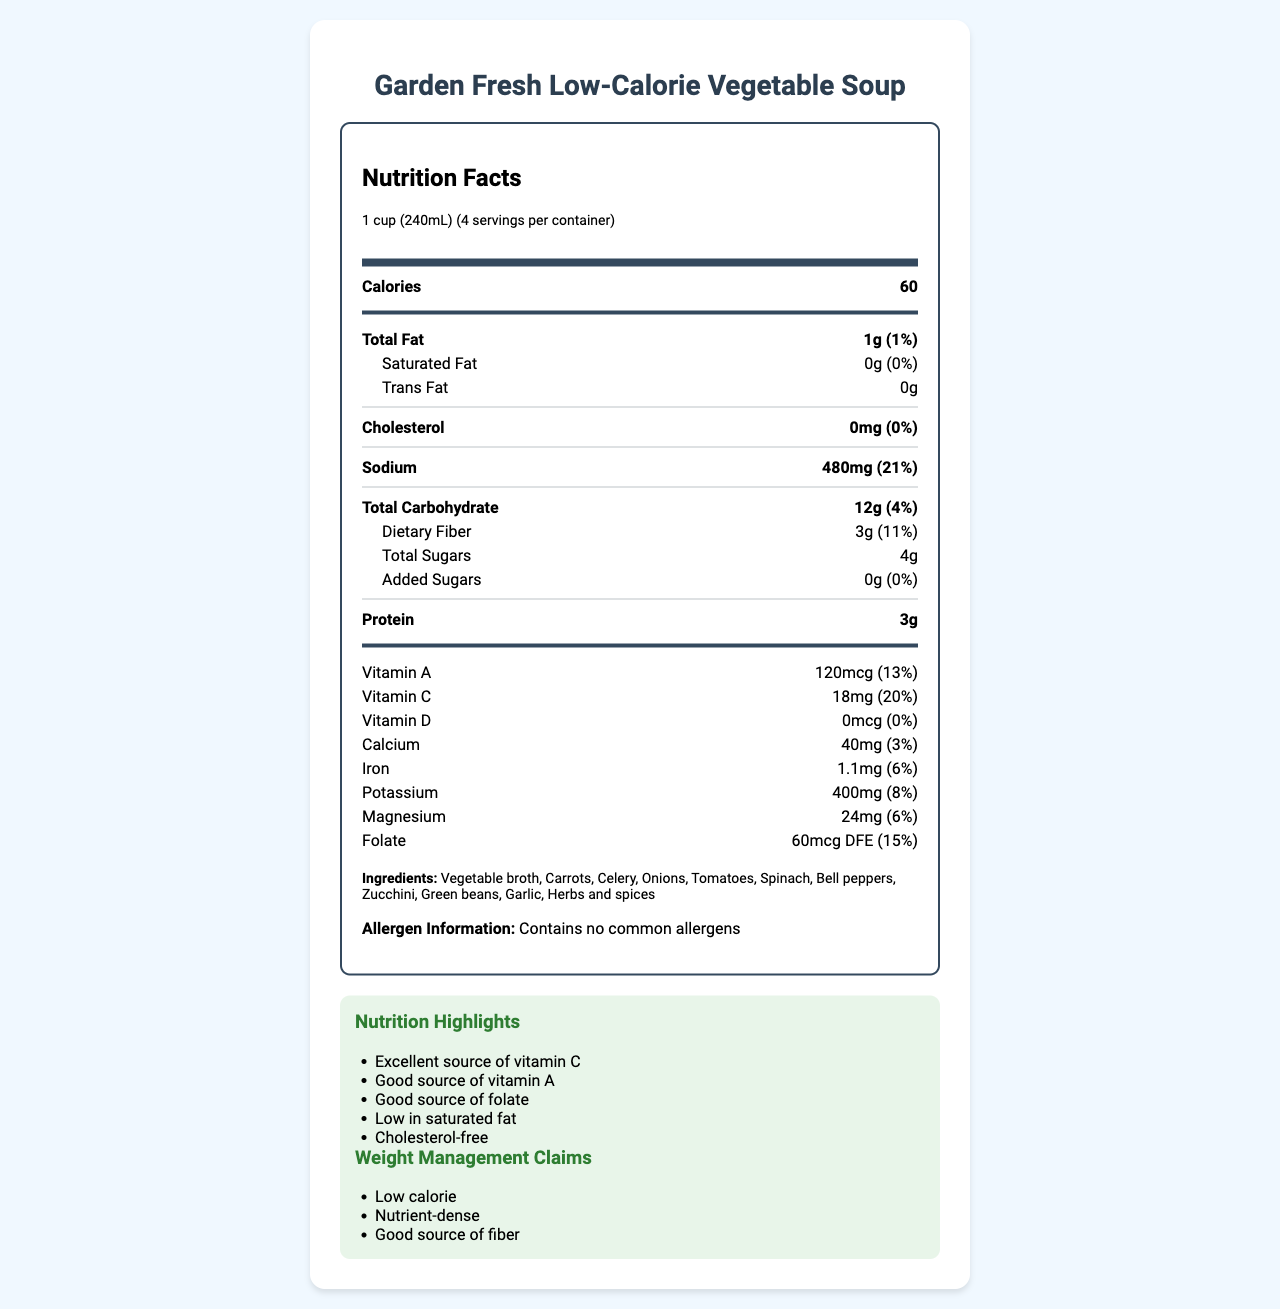what is the calories per serving? The number of calories per serving is listed as 60 in the nutrition label.
Answer: 60 how many grams of total fat are in one cup of soup? The label indicates that the soup contains 1g of total fat per serving.
Answer: 1g what vitamins are this soup a good source of? The nutrition highlights indicate that the soup is a good source of vitamin A, vitamin C, and folate.
Answer: vitamin A, vitamin C, folate how much sodium is in one serving of this soup? The nutrition label shows that there are 480mg of sodium per serving.
Answer: 480mg how many grams of dietary fiber are there in a serving? Under the total carbohydrate section, it’s specified that there are 3g of dietary fiber.
Answer: 3g what is the percentage of daily value for calcium per serving? A. 3% B. 8% C. 20% D. 13% The percentage daily value of calcium is 3%.
Answer: A. 3% which of the following is not an ingredient in the soup? I. Tomatoes II. Celery III. Milk IV. Bell pepper The ingredient list includes tomatoes, celery, and bell pepper, but not milk.
Answer: III. Milk is this product cholesterol-free? The label shows 0mg of cholesterol, meaning it is cholesterol-free.
Answer: Yes what is the main idea of this document? The document contains detailed nutritional information about the Garden Fresh Low-Calorie Vegetable Soup, including calorie content, amounts of fats, carbohydrates, proteins, vitamins, minerals, and ingredients.
Answer: The document provides the nutrition facts and key highlights for the Garden Fresh Low-Calorie Vegetable Soup, which includes its serving size, nutritional content per serving, ingredients, allergen information, and health claims. how much protein is in one serving of this soup? The nutrition label indicates that each serving contains 3g of protein.
Answer: 3g can I make any deductions about the sugar source in this soup? The label shows total sugars and added sugars but does not specify the source of the sugars.
Answer: Not enough information which nutrients are this soup an excellent or good source of? The nutrition highlights specifically mention that the soup is an excellent source of vitamin C and a good source of vitamin A and folate.
Answer: vitamin C, vitamin A, folate what size is a single serving of this soup? The serving size listed on the label is 1 cup (240mL).
Answer: 1 cup (240mL) how much iron is contained per serving and its percentage of daily value? The nutrition label specifies that each serving contains 1.1mg of iron, which equals 6% of the daily value.
Answer: 1.1mg, 6% is the soup high in saturated fat? The label indicates 0g of saturated fat, which is 0% of the daily value.
Answer: No 